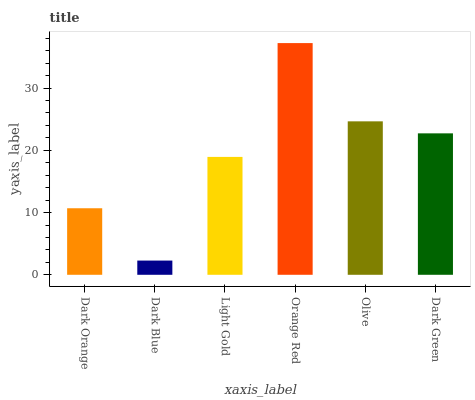Is Dark Blue the minimum?
Answer yes or no. Yes. Is Orange Red the maximum?
Answer yes or no. Yes. Is Light Gold the minimum?
Answer yes or no. No. Is Light Gold the maximum?
Answer yes or no. No. Is Light Gold greater than Dark Blue?
Answer yes or no. Yes. Is Dark Blue less than Light Gold?
Answer yes or no. Yes. Is Dark Blue greater than Light Gold?
Answer yes or no. No. Is Light Gold less than Dark Blue?
Answer yes or no. No. Is Dark Green the high median?
Answer yes or no. Yes. Is Light Gold the low median?
Answer yes or no. Yes. Is Dark Blue the high median?
Answer yes or no. No. Is Orange Red the low median?
Answer yes or no. No. 